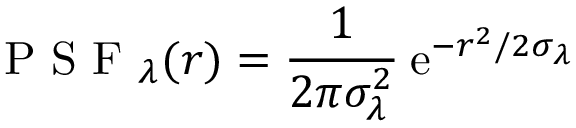<formula> <loc_0><loc_0><loc_500><loc_500>P S F _ { \lambda } ( r ) = \frac { 1 } { 2 \pi \sigma _ { \lambda } ^ { 2 } } \, e ^ { - r ^ { 2 } / 2 \sigma _ { \lambda } }</formula> 